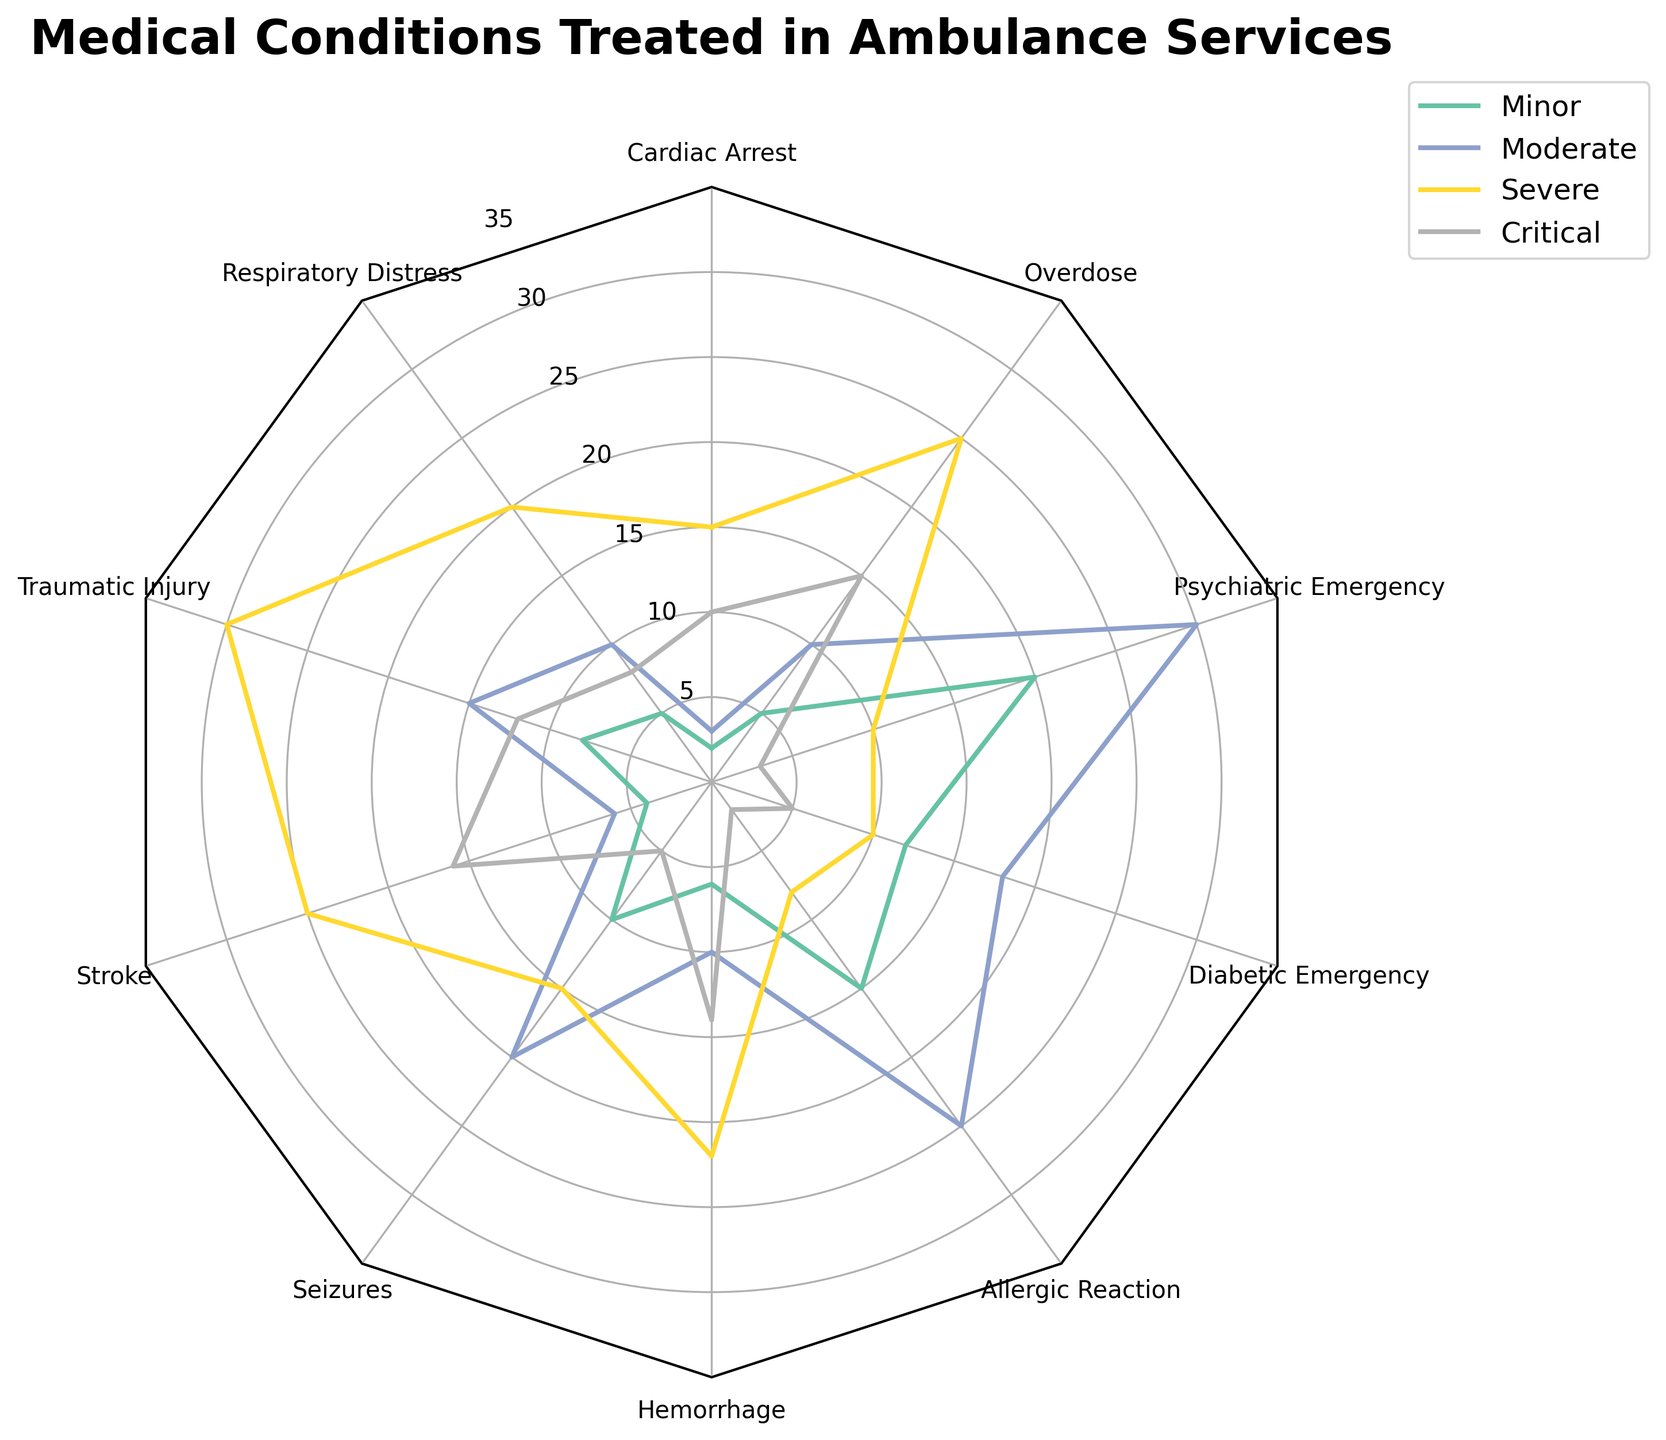What medical condition has the highest frequency at the severe level? By looking at the radar chart, we see that 'Traumatic Injury' has the highest spike in the severe category.
Answer: Traumatic Injury Which severity level shows a minimal difference across all medical conditions? Examine the radar chart for the severity levels where the edges are closest to each other. The 'Minor' category appears to show the least variation.
Answer: Minor How many medical conditions have at least one severity level of above 20? Check each spoke on the radar chart for spikes that go beyond the 20 mark in any of the severity levels. Conditions like 'Respiratory Distress,' 'Traumatic Injury,' 'Stroke,' 'Hemorrhage,' 'Overdose,' and 'Seizures' qualify.
Answer: 6 Which medical condition has the largest range between its highest and lowest severity levels? Evaluate the spikes across all severity levels for each condition. 'Traumatic Injury' has a range from 8 (Minor) to 30 (Severe).
Answer: Traumatic Injury Between 'Cardiac Arrest' and 'Overdose,' which shows more cases at the critical level? Compare the height of the spikes for 'Cardiac Arrest' and 'Overdose' in the Critical severity level section of the radar chart. 'Cardiac Arrest' has fewer cases than 'Overdose.'
Answer: Overdose What is the total number of cases for 'Psychiatric Emergency' across all severity levels? Add the numbers from the radar chart data for 'Psychiatric Emergency' across Minor, Moderate, Severe, and Critical levels: 20 (Minor) + 30 (Moderate) + 10 (Severe) + 3 (Critical).
Answer: 63 Which severity level has the highest frequency for 'Allergic Reaction'? Look at the radar chart and identify the highest spike for 'Allergic Reaction' among all severity levels. It is highest in the 'Moderate' category.
Answer: Moderate Does 'Stroke' have more severe or moderate cases? Compare the comparatively lower spike in 'Moderate' with the higher spike in 'Severe' for 'Stroke' in the radar chart. 'Stroke' has more cases at the severe level.
Answer: Severe Which medical condition has the lowest frequency in the critical category? Check the radar chart for the smallest spike in the Critical category. 'Allergic Reaction' and 'Psychiatric Emergency' both have low values here, but 'Allergic Reaction' has the lowest with 2 cases.
Answer: Allergic Reaction 